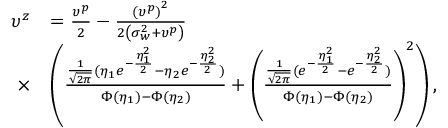Convert formula to latex. <formula><loc_0><loc_0><loc_500><loc_500>\begin{array} { r l } { \upsilon ^ { z } } & { = \frac { \upsilon ^ { p } } { 2 } - \frac { { { \left ( { { \upsilon } ^ { p } } \right ) } ^ { 2 } } } { 2 \left ( \sigma _ { w } ^ { 2 } + { { \upsilon } ^ { p } } \right ) } } \\ { \times } & { \left ( \frac { \frac { 1 } { \sqrt { 2 \pi } } ( \eta _ { 1 } e ^ { - \frac { \eta _ { 1 } ^ { 2 } } { 2 } } - \eta _ { 2 } e ^ { - \frac { \eta _ { 2 } ^ { 2 } } { 2 } } ) } { \Phi ( \eta _ { 1 } ) - \Phi ( \eta _ { 2 } ) } + \left ( \frac { \frac { 1 } { \sqrt { 2 \pi } } ( e ^ { - \frac { \eta _ { 1 } ^ { 2 } } { 2 } } - e ^ { - \frac { \eta _ { 2 } ^ { 2 } } { 2 } } ) } { \Phi ( \eta _ { 1 } ) - \Phi ( \eta _ { 2 } ) } \right ) ^ { 2 } \right ) , } \end{array}</formula> 